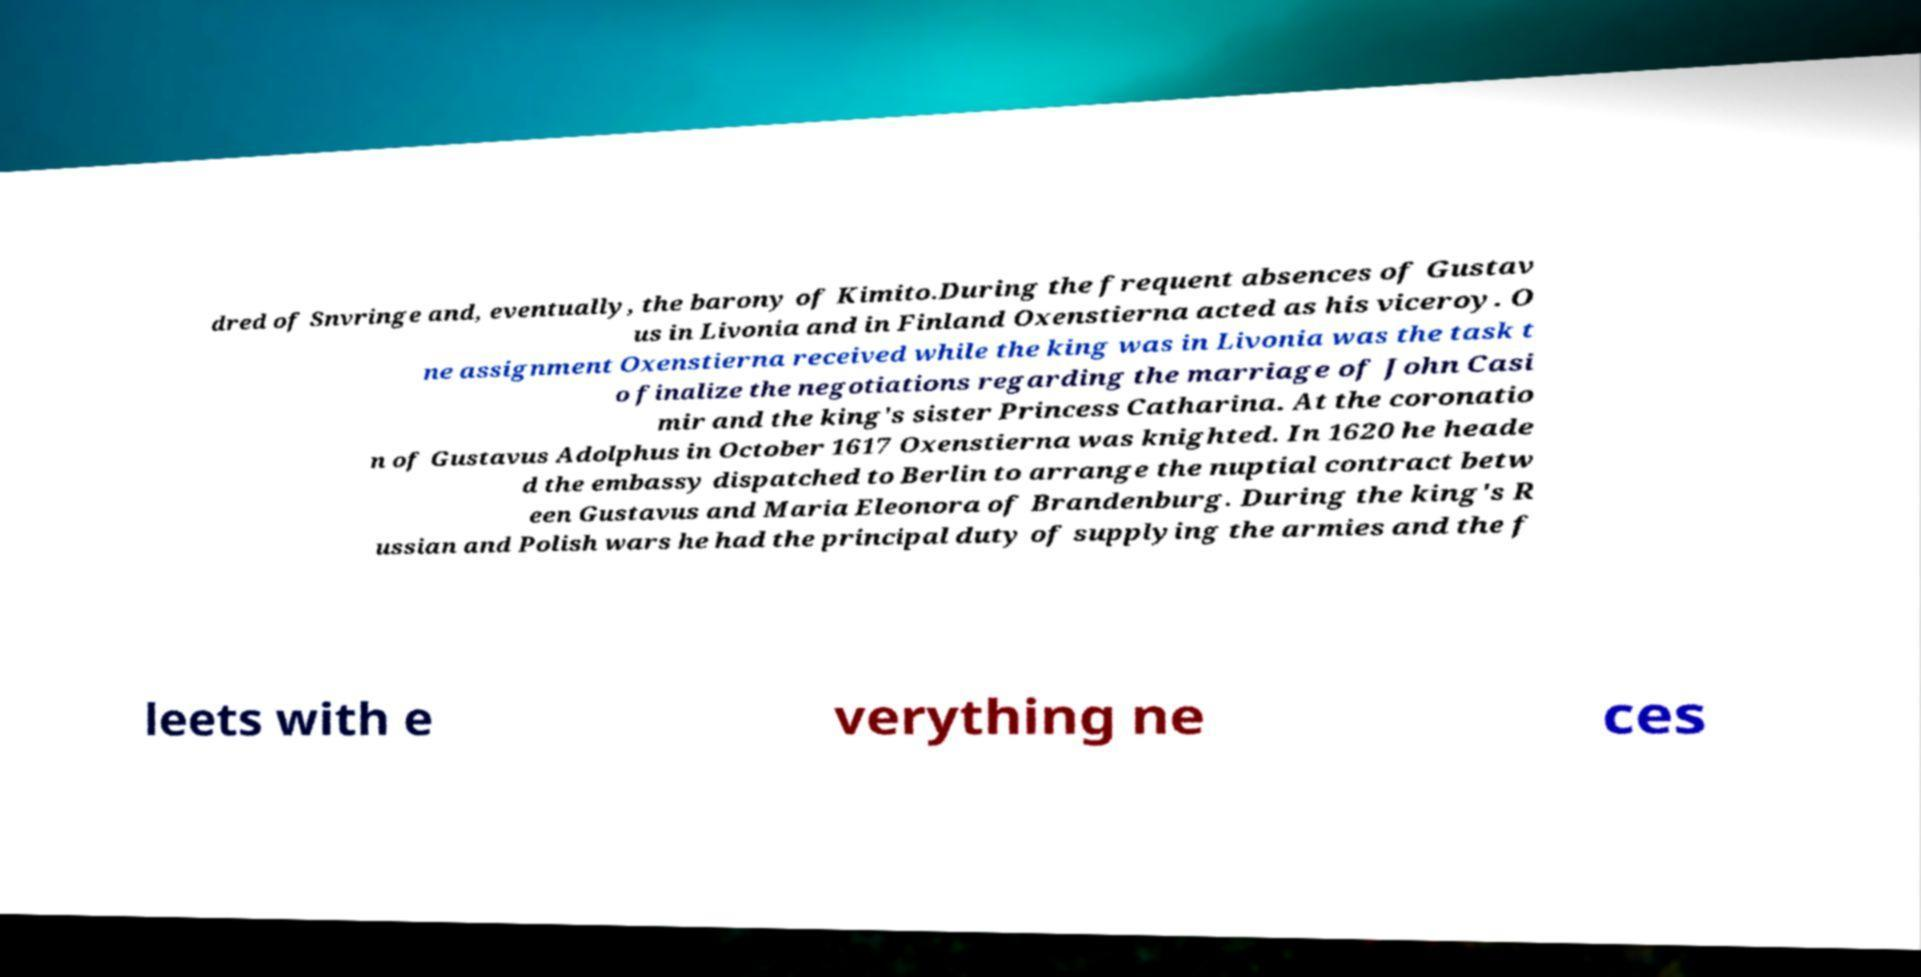I need the written content from this picture converted into text. Can you do that? dred of Snvringe and, eventually, the barony of Kimito.During the frequent absences of Gustav us in Livonia and in Finland Oxenstierna acted as his viceroy. O ne assignment Oxenstierna received while the king was in Livonia was the task t o finalize the negotiations regarding the marriage of John Casi mir and the king's sister Princess Catharina. At the coronatio n of Gustavus Adolphus in October 1617 Oxenstierna was knighted. In 1620 he heade d the embassy dispatched to Berlin to arrange the nuptial contract betw een Gustavus and Maria Eleonora of Brandenburg. During the king's R ussian and Polish wars he had the principal duty of supplying the armies and the f leets with e verything ne ces 